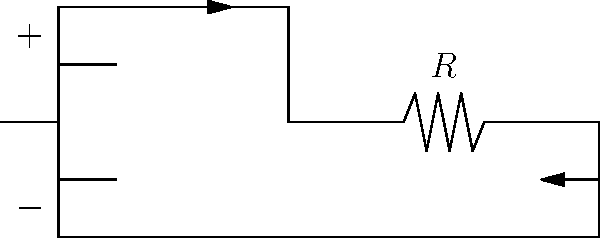In the circuit shown, a battery is connected to a resistor. Considering the conventional current flow, what is the direction of current in this circuit? To determine the direction of current flow in this circuit, we need to follow these steps:

1. Identify the battery's polarity:
   - The longer line represents the positive (+) terminal
   - The shorter line represents the negative (-) terminal

2. Recall the convention for current flow:
   - Conventional current flows from the positive terminal to the negative terminal of the battery in the external circuit

3. Trace the path of current:
   - Current leaves the positive terminal of the battery
   - Flows through the top wire to the resistor
   - Passes through the resistor
   - Returns to the battery through the bottom wire
   - Enters the negative terminal of the battery

4. Observe the arrows in the diagram:
   - The arrows indicate the direction of current flow
   - They show current flowing clockwise in the circuit

This clockwise flow from positive to negative is consistent with the conventional current flow in electrical circuits.
Answer: Clockwise 